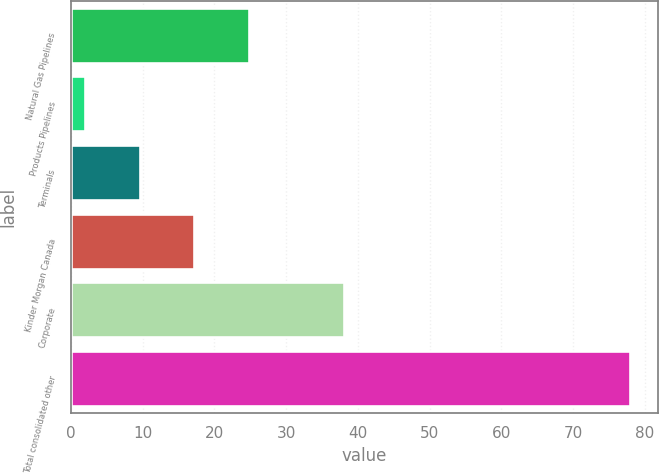<chart> <loc_0><loc_0><loc_500><loc_500><bar_chart><fcel>Natural Gas Pipelines<fcel>Products Pipelines<fcel>Terminals<fcel>Kinder Morgan Canada<fcel>Corporate<fcel>Total consolidated other<nl><fcel>24.8<fcel>2<fcel>9.6<fcel>17.2<fcel>38<fcel>78<nl></chart> 